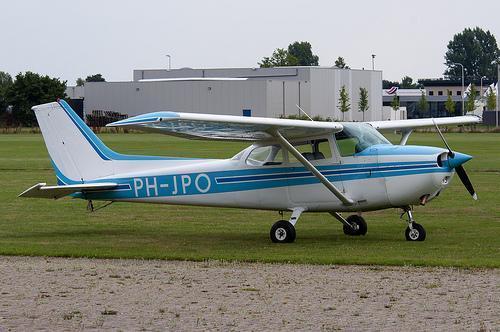How many wheels on the plane?
Give a very brief answer. 3. How many buildings are there?
Give a very brief answer. 2. How many monkeys are on top of the plane?
Give a very brief answer. 0. How many wheels does the small airplane has ?
Give a very brief answer. 3. 